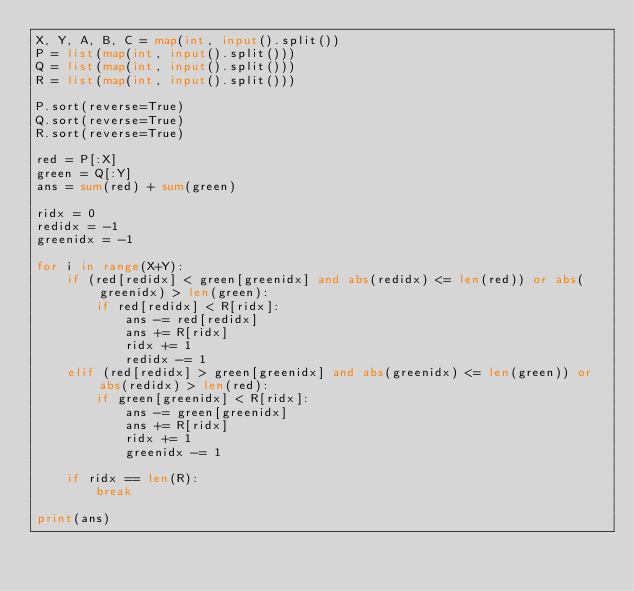<code> <loc_0><loc_0><loc_500><loc_500><_Python_>X, Y, A, B, C = map(int, input().split())
P = list(map(int, input().split()))
Q = list(map(int, input().split()))
R = list(map(int, input().split()))

P.sort(reverse=True)
Q.sort(reverse=True)
R.sort(reverse=True)

red = P[:X]
green = Q[:Y]
ans = sum(red) + sum(green)

ridx = 0
redidx = -1
greenidx = -1

for i in range(X+Y):
    if (red[redidx] < green[greenidx] and abs(redidx) <= len(red)) or abs(greenidx) > len(green):
        if red[redidx] < R[ridx]:
            ans -= red[redidx]
            ans += R[ridx]
            ridx += 1
            redidx -= 1
    elif (red[redidx] > green[greenidx] and abs(greenidx) <= len(green)) or abs(redidx) > len(red):
        if green[greenidx] < R[ridx]:
            ans -= green[greenidx]
            ans += R[ridx]
            ridx += 1
            greenidx -= 1

    if ridx == len(R):
        break

print(ans)
</code> 